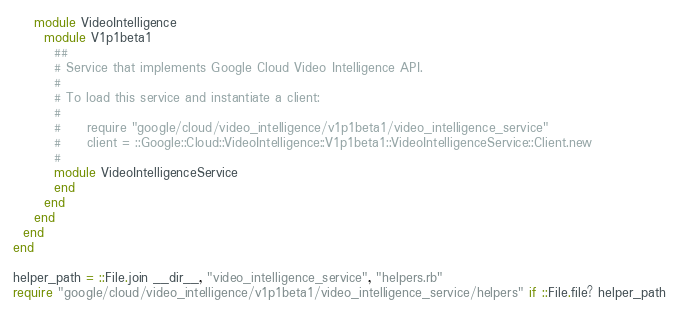<code> <loc_0><loc_0><loc_500><loc_500><_Ruby_>    module VideoIntelligence
      module V1p1beta1
        ##
        # Service that implements Google Cloud Video Intelligence API.
        #
        # To load this service and instantiate a client:
        #
        #     require "google/cloud/video_intelligence/v1p1beta1/video_intelligence_service"
        #     client = ::Google::Cloud::VideoIntelligence::V1p1beta1::VideoIntelligenceService::Client.new
        #
        module VideoIntelligenceService
        end
      end
    end
  end
end

helper_path = ::File.join __dir__, "video_intelligence_service", "helpers.rb"
require "google/cloud/video_intelligence/v1p1beta1/video_intelligence_service/helpers" if ::File.file? helper_path
</code> 